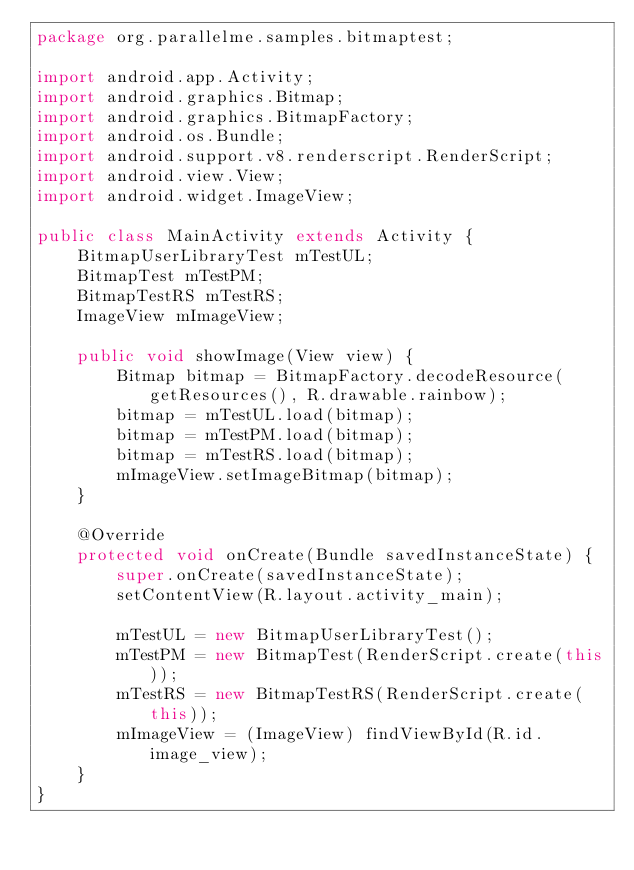<code> <loc_0><loc_0><loc_500><loc_500><_Java_>package org.parallelme.samples.bitmaptest;

import android.app.Activity;
import android.graphics.Bitmap;
import android.graphics.BitmapFactory;
import android.os.Bundle;
import android.support.v8.renderscript.RenderScript;
import android.view.View;
import android.widget.ImageView;

public class MainActivity extends Activity {
    BitmapUserLibraryTest mTestUL;
    BitmapTest mTestPM;
    BitmapTestRS mTestRS;
    ImageView mImageView;

    public void showImage(View view) {
        Bitmap bitmap = BitmapFactory.decodeResource(getResources(), R.drawable.rainbow);
        bitmap = mTestUL.load(bitmap);
        bitmap = mTestPM.load(bitmap);
        bitmap = mTestRS.load(bitmap);
        mImageView.setImageBitmap(bitmap);
    }

    @Override
    protected void onCreate(Bundle savedInstanceState) {
        super.onCreate(savedInstanceState);
        setContentView(R.layout.activity_main);

        mTestUL = new BitmapUserLibraryTest();
        mTestPM = new BitmapTest(RenderScript.create(this));
        mTestRS = new BitmapTestRS(RenderScript.create(this));
        mImageView = (ImageView) findViewById(R.id.image_view);
    }
}
</code> 